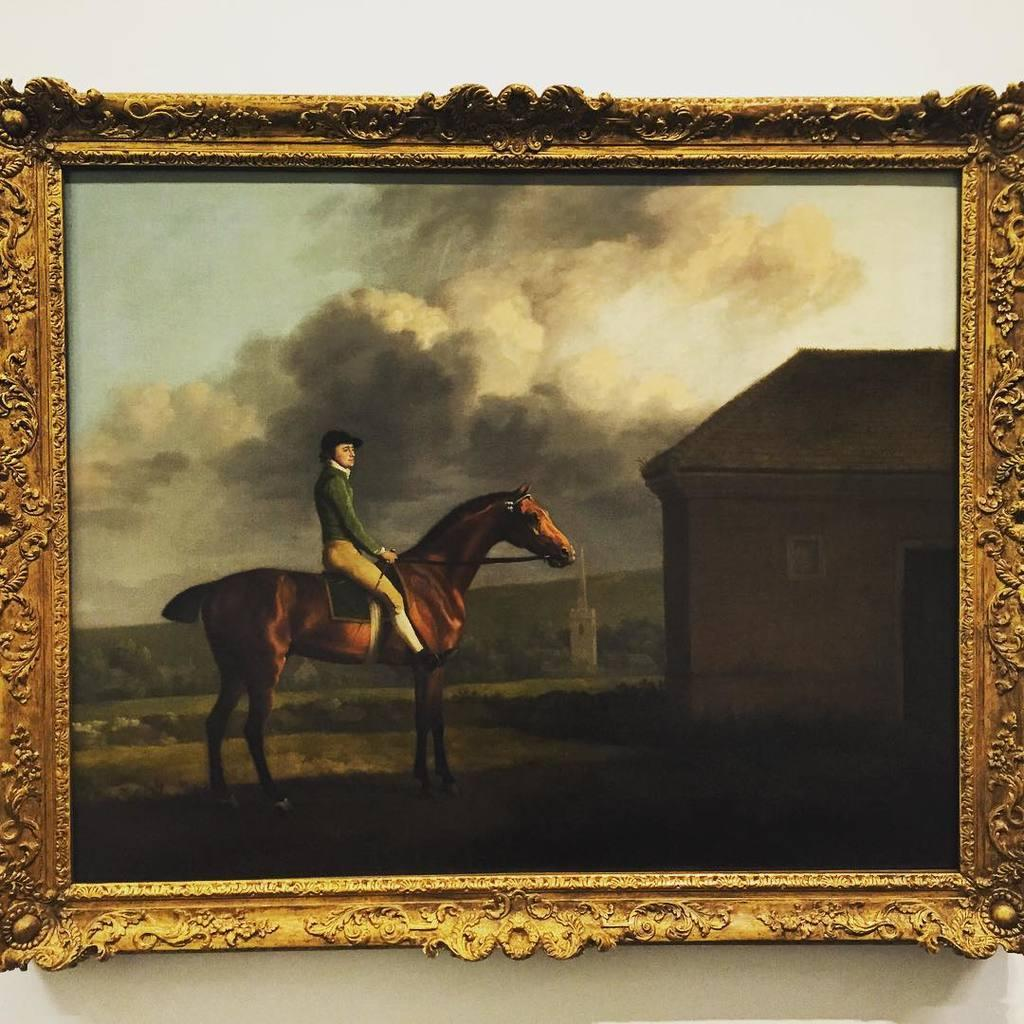What is the main subject of the image? There is a painting in the image. Can you describe the frame of the painting? The painting has a golden frame. What is the scene depicted in the painting? The painting depicts a man sitting on a horse, and the man is in front of a hut. What is the surrounding environment of the hut? The hut is surrounded by grass. What is visible in the sky in the painting? There are clouds visible at the top of the painting. Can you see a rabbit in the painting? There is no rabbit present in the painting. 